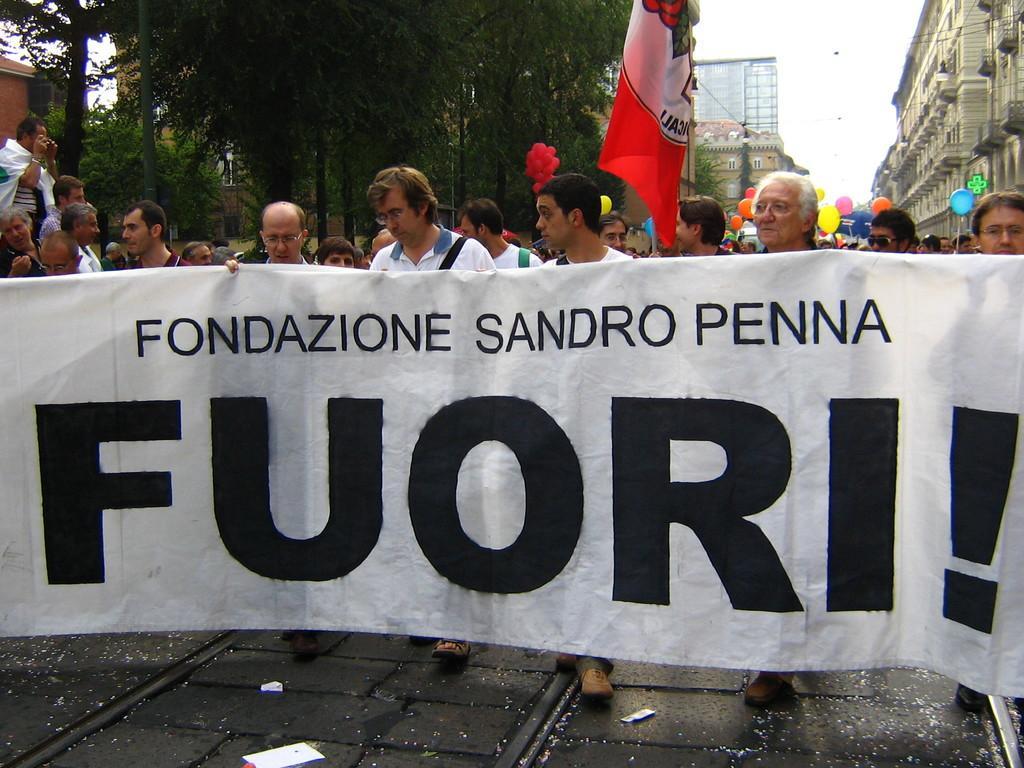Could you give a brief overview of what you see in this image? In this picture, we can see a few people, and a few are holding some objects like posters, flags and balloons, we can see buildings with windows, ground, trees, and the sky with clouds. 